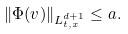<formula> <loc_0><loc_0><loc_500><loc_500>\| \Phi ( v ) \| _ { L _ { t , x } ^ { d + 1 } } \leq a .</formula> 